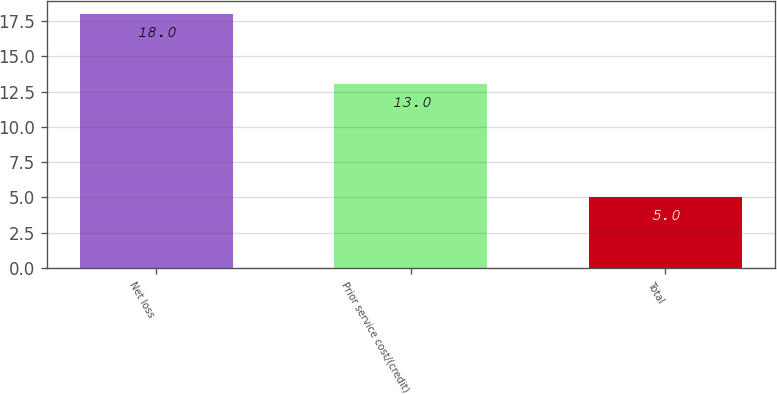<chart> <loc_0><loc_0><loc_500><loc_500><bar_chart><fcel>Net loss<fcel>Prior service cost/(credit)<fcel>Total<nl><fcel>18<fcel>13<fcel>5<nl></chart> 